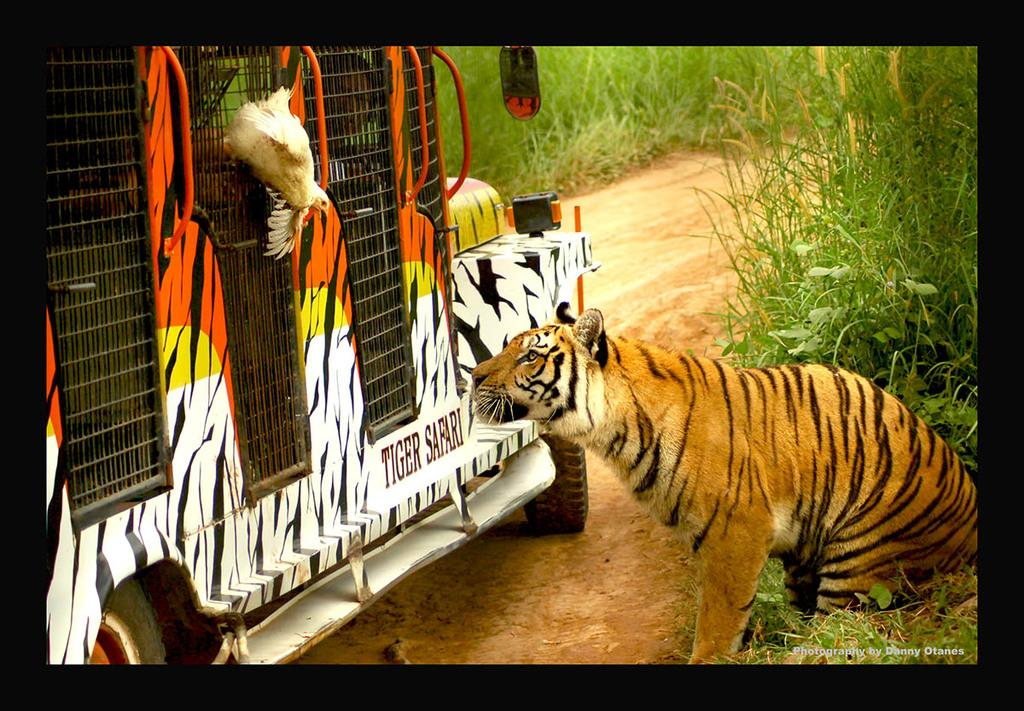What types of living organisms can be seen in the image? There are animals in the image. What else can be seen in the image besides the animals? There is a vehicle in the image. What is the surface on which the animals and vehicle are situated? The ground is visible in the image. What type of vegetation is present in the image? There is grass and plants in the image. Can you tell me how many times the alarm goes off in the image? There is no alarm present in the image, so it cannot be determined how many times it goes off. 